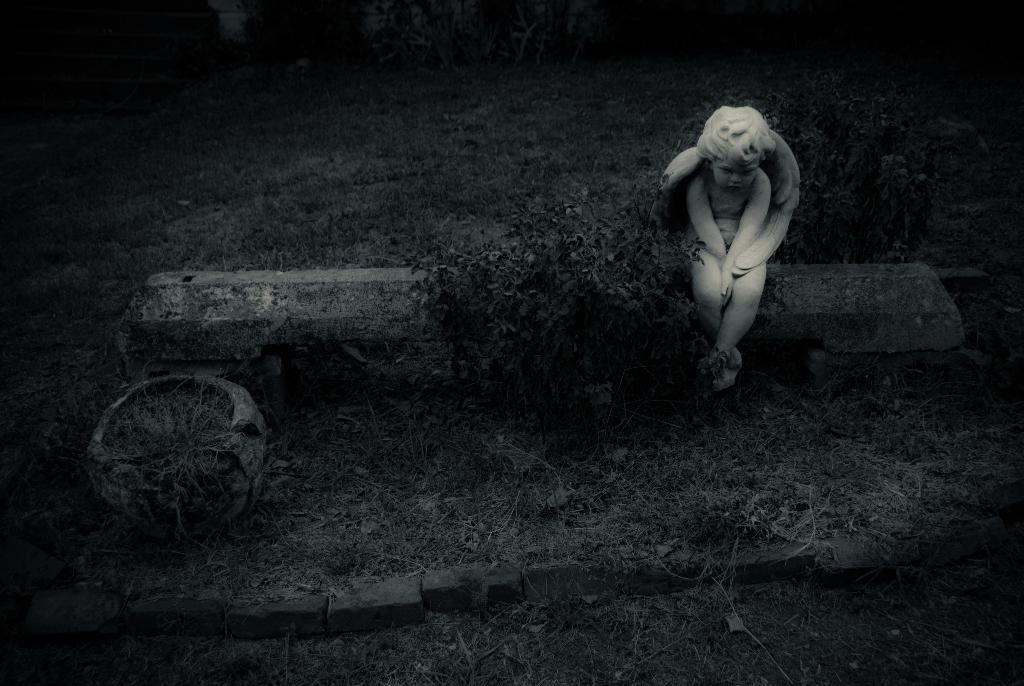What is on top of the pole in the image? There is a statue on a pole in the image. What type of vegetation can be seen in the image? There are plants visible in the image. What covers the ground in the image? There is grass on the ground in the image. What type of hospital can be seen in the image? There is no hospital present in the image. What nut is being used to hold the statue on the pole in the image? There is no nut visible in the image, and the statue is not held in place by a nut. 